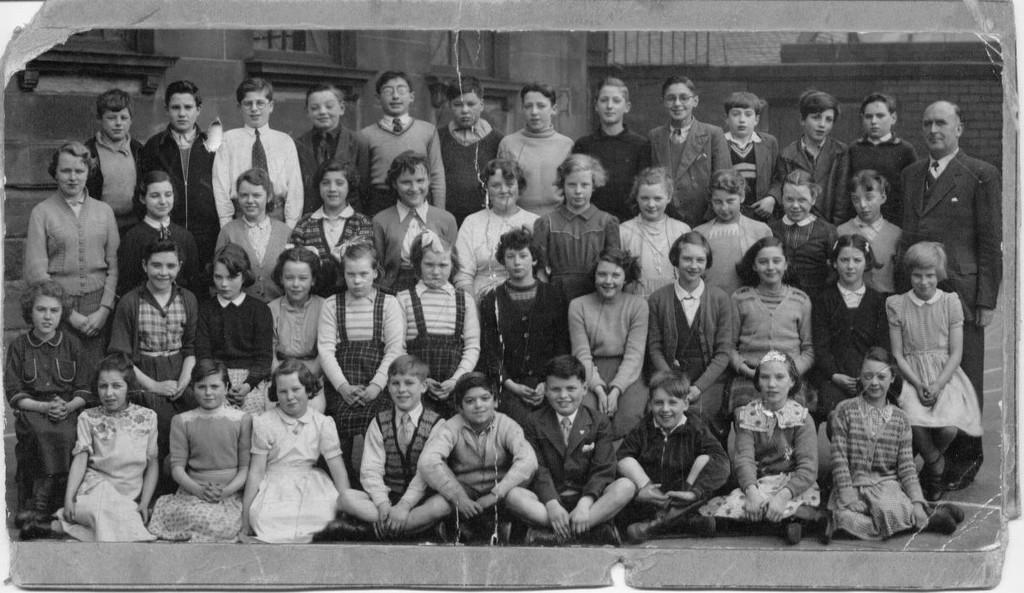Can you describe this image briefly? In this picture we can find few people are posing for a picture, in the first and second row people are sitting and in the third and fourth row people are standing, the picture is taken in black and white. 